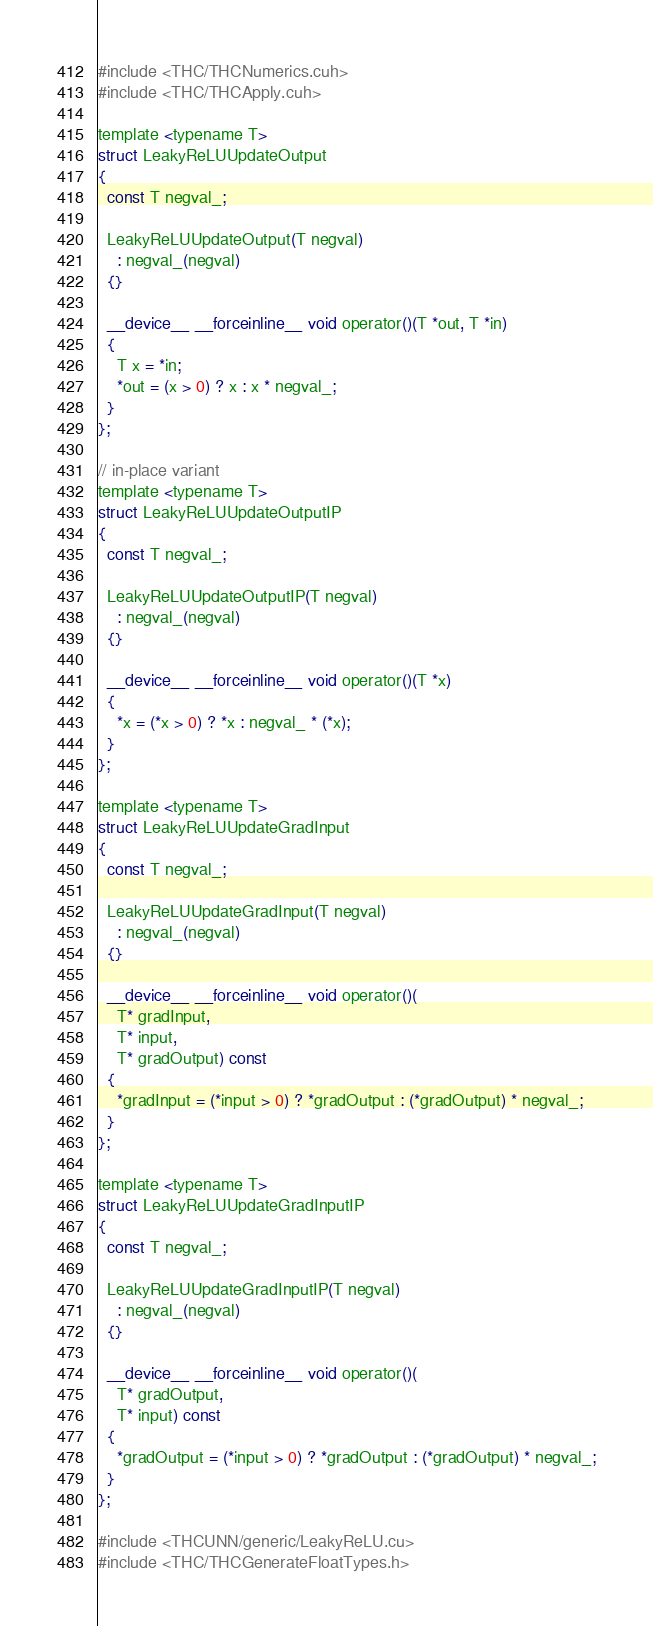<code> <loc_0><loc_0><loc_500><loc_500><_Cuda_>#include <THC/THCNumerics.cuh>
#include <THC/THCApply.cuh>

template <typename T>
struct LeakyReLUUpdateOutput
{
  const T negval_;

  LeakyReLUUpdateOutput(T negval)
    : negval_(negval)
  {}

  __device__ __forceinline__ void operator()(T *out, T *in)
  {
    T x = *in;
    *out = (x > 0) ? x : x * negval_;
  }
};

// in-place variant
template <typename T>
struct LeakyReLUUpdateOutputIP
{
  const T negval_;

  LeakyReLUUpdateOutputIP(T negval)
    : negval_(negval)
  {}

  __device__ __forceinline__ void operator()(T *x)
  {
    *x = (*x > 0) ? *x : negval_ * (*x);
  }
};

template <typename T>
struct LeakyReLUUpdateGradInput
{
  const T negval_;

  LeakyReLUUpdateGradInput(T negval)
    : negval_(negval)
  {}

  __device__ __forceinline__ void operator()(
    T* gradInput,
    T* input,
    T* gradOutput) const
  {
    *gradInput = (*input > 0) ? *gradOutput : (*gradOutput) * negval_;
  }
};

template <typename T>
struct LeakyReLUUpdateGradInputIP
{
  const T negval_;

  LeakyReLUUpdateGradInputIP(T negval)
    : negval_(negval)
  {}

  __device__ __forceinline__ void operator()(
    T* gradOutput,
    T* input) const
  {
    *gradOutput = (*input > 0) ? *gradOutput : (*gradOutput) * negval_;
  }
};

#include <THCUNN/generic/LeakyReLU.cu>
#include <THC/THCGenerateFloatTypes.h>
</code> 